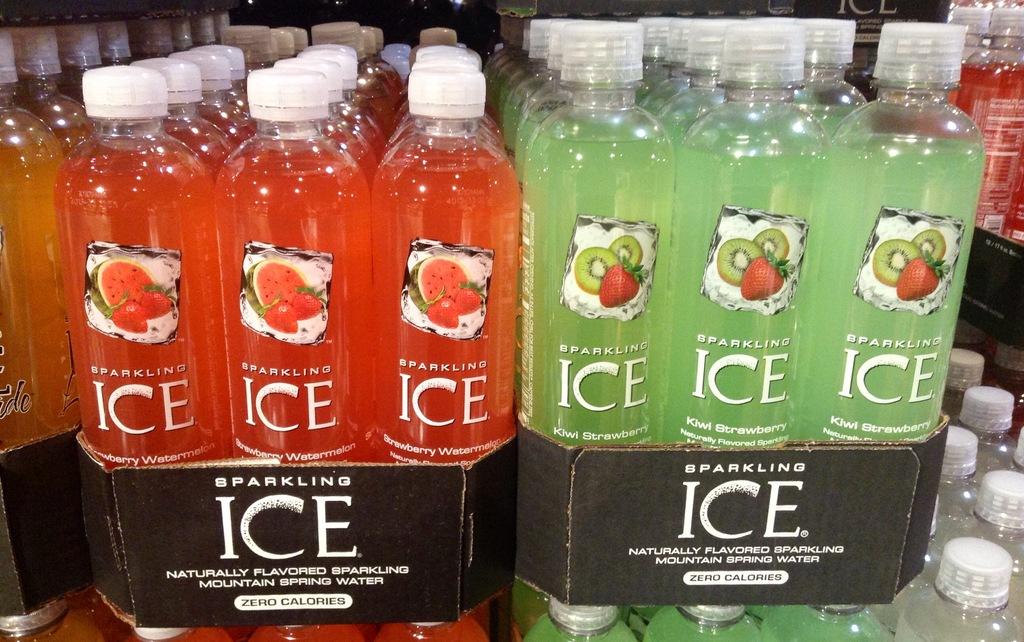What flavor is the green beverage?
Give a very brief answer. Kiwi strawberry. 